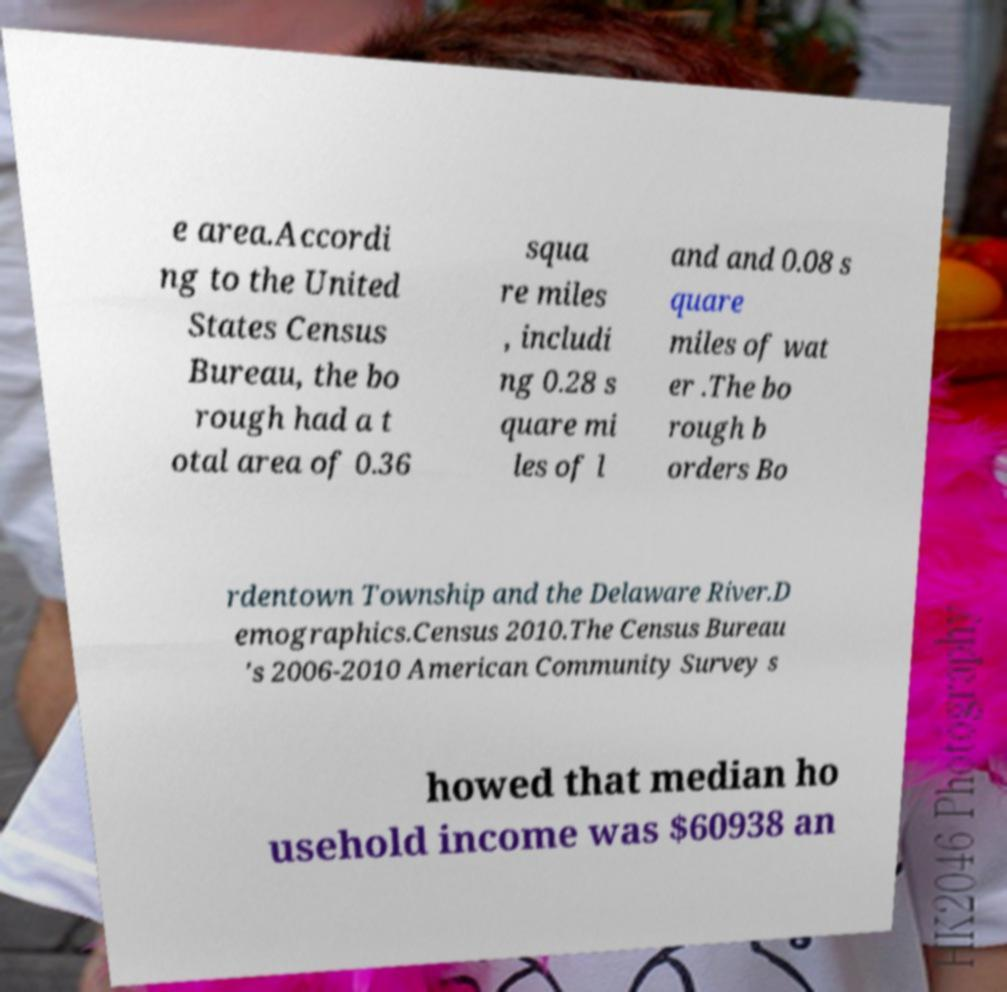Can you read and provide the text displayed in the image?This photo seems to have some interesting text. Can you extract and type it out for me? e area.Accordi ng to the United States Census Bureau, the bo rough had a t otal area of 0.36 squa re miles , includi ng 0.28 s quare mi les of l and and 0.08 s quare miles of wat er .The bo rough b orders Bo rdentown Township and the Delaware River.D emographics.Census 2010.The Census Bureau 's 2006-2010 American Community Survey s howed that median ho usehold income was $60938 an 